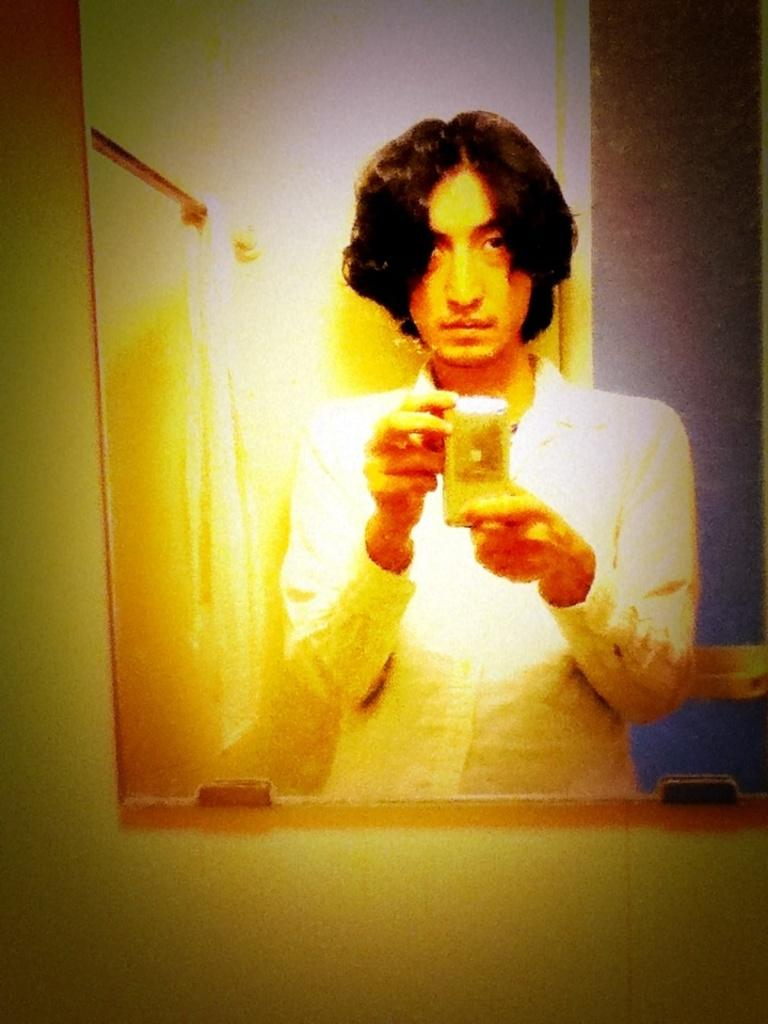What is the main subject of the picture? The main subject of the picture is a man. What is the man doing in the picture? The man is standing and clicking a picture. What object is present in front of the man? There is a mirror in front of the man. What type of oatmeal can be seen on the edge of the foot in the image? There is no oatmeal or foot present in the image, so this question cannot be answered. 